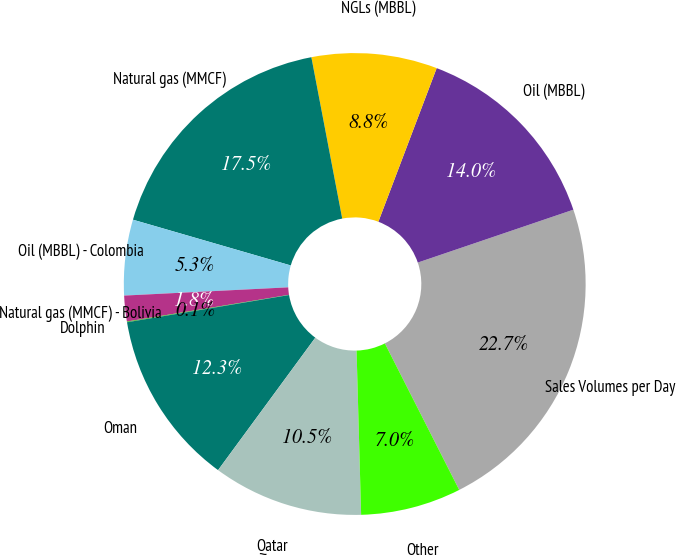Convert chart to OTSL. <chart><loc_0><loc_0><loc_500><loc_500><pie_chart><fcel>Sales Volumes per Day<fcel>Oil (MBBL)<fcel>NGLs (MBBL)<fcel>Natural gas (MMCF)<fcel>Oil (MBBL) - Colombia<fcel>Natural gas (MMCF) - Bolivia<fcel>Dolphin<fcel>Oman<fcel>Qatar<fcel>Other<nl><fcel>22.74%<fcel>14.01%<fcel>8.78%<fcel>17.5%<fcel>5.29%<fcel>1.8%<fcel>0.05%<fcel>12.27%<fcel>10.52%<fcel>7.03%<nl></chart> 